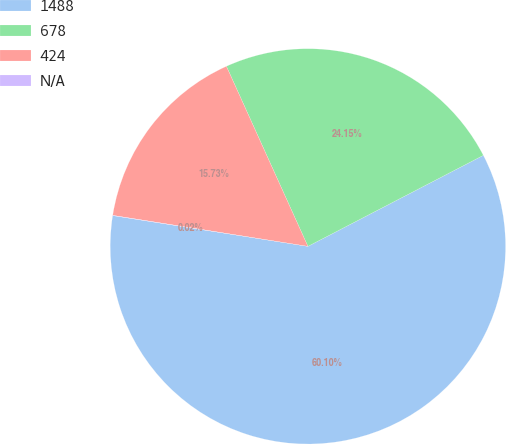Convert chart. <chart><loc_0><loc_0><loc_500><loc_500><pie_chart><fcel>1488<fcel>678<fcel>424<fcel>N/A<nl><fcel>60.11%<fcel>24.15%<fcel>15.73%<fcel>0.02%<nl></chart> 